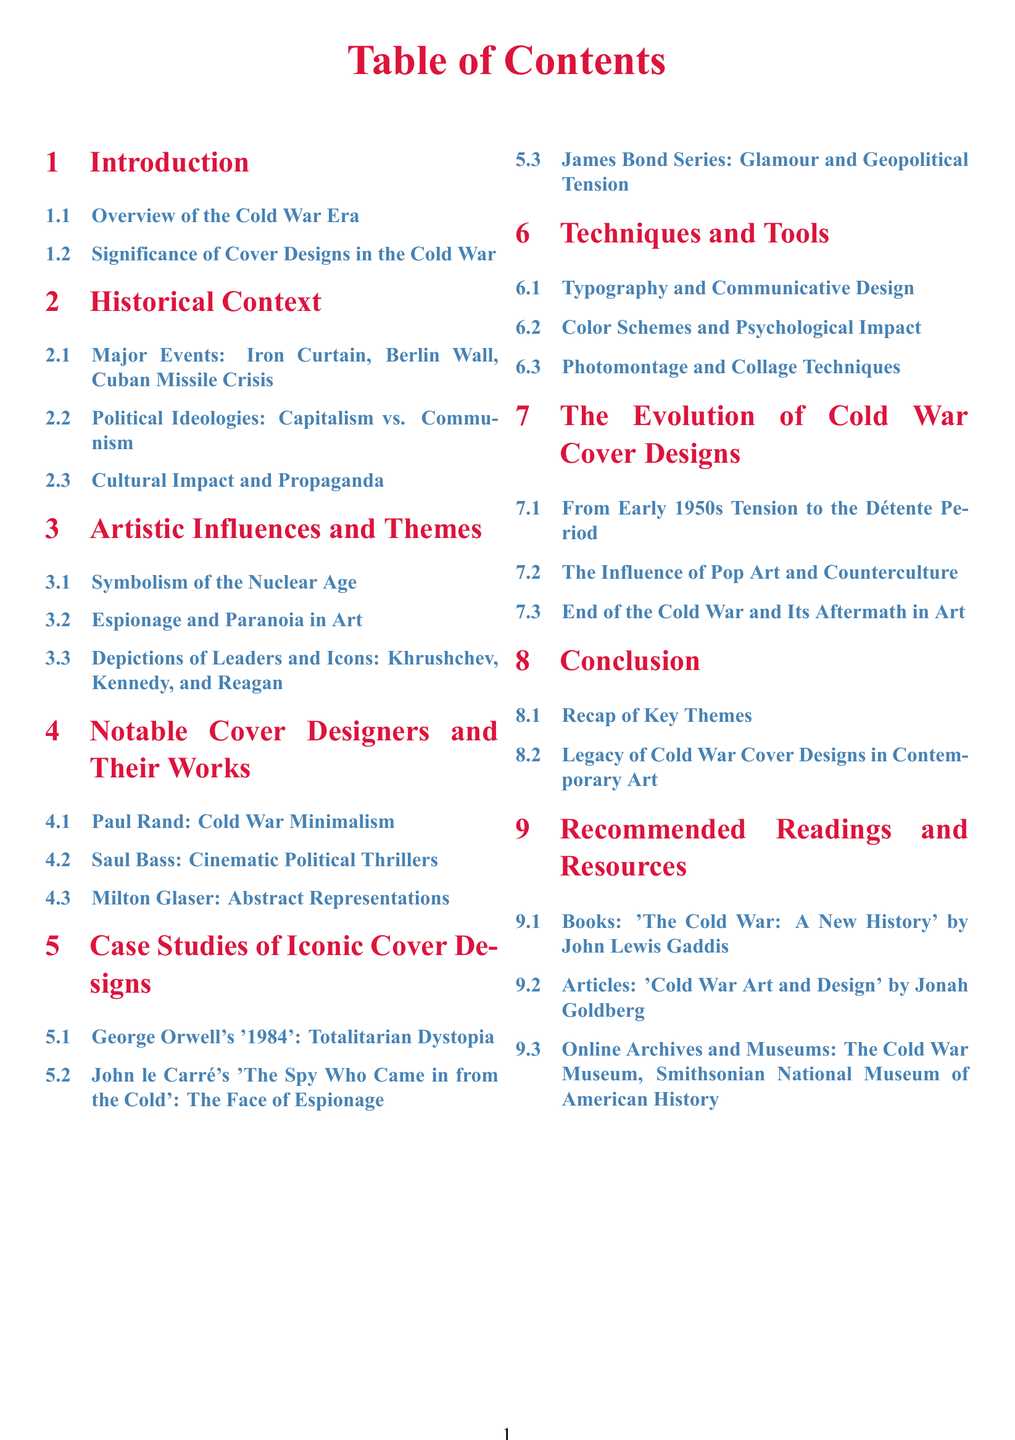What is the title of the first section? The first section title can be found in the Table of Contents, which lists the sections and their titles.
Answer: Introduction How many subsections are under "Historical Context"? The number of subsections can be counted from the listed subsections under the "Historical Context" section.
Answer: 3 Who is the designer associated with Cold War minimalism? The designer's name can be found in the "Notable Cover Designers and Their Works" section.
Answer: Paul Rand What major event is associated with the Berlin Wall? The Berlin Wall is a significant event listed in the "Historical Context" section; it can be directly referenced to understand its context.
Answer: Iron Curtain Which book is recommended under "Recommended Readings and Resources"? The title of the book can be found in the "Recommended Readings and Resources" section, which lists specific resources.
Answer: The Cold War: A New History What artistic theme is explored in the section titled "Artistic Influences and Themes"? The section provides insights into themes explored by artists related to the Cold War era.
Answer: Symbolism of the Nuclear Age How many sections are there in total? The total number of sections can be counted from the Table of Contents.
Answer: 8 What color is used for the section titles? The color of section titles can be determined based on the formatting defined in the document.
Answer: Soviet Red 